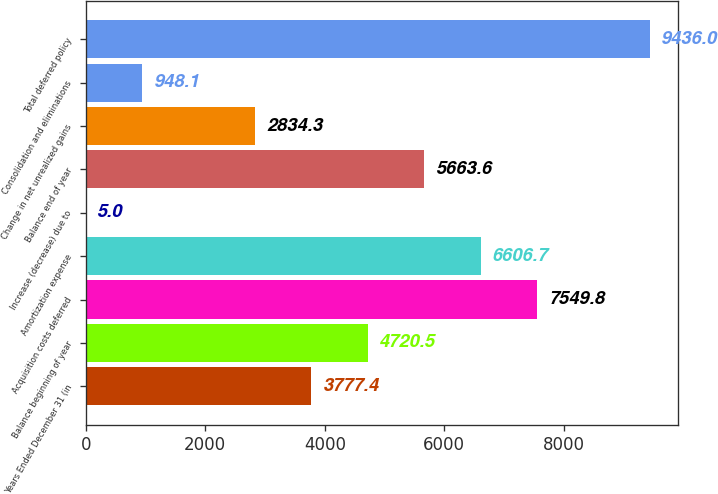Convert chart. <chart><loc_0><loc_0><loc_500><loc_500><bar_chart><fcel>Years Ended December 31 (in<fcel>Balance beginning of year<fcel>Acquisition costs deferred<fcel>Amortization expense<fcel>Increase (decrease) due to<fcel>Balance end of year<fcel>Change in net unrealized gains<fcel>Consolidation and eliminations<fcel>Total deferred policy<nl><fcel>3777.4<fcel>4720.5<fcel>7549.8<fcel>6606.7<fcel>5<fcel>5663.6<fcel>2834.3<fcel>948.1<fcel>9436<nl></chart> 